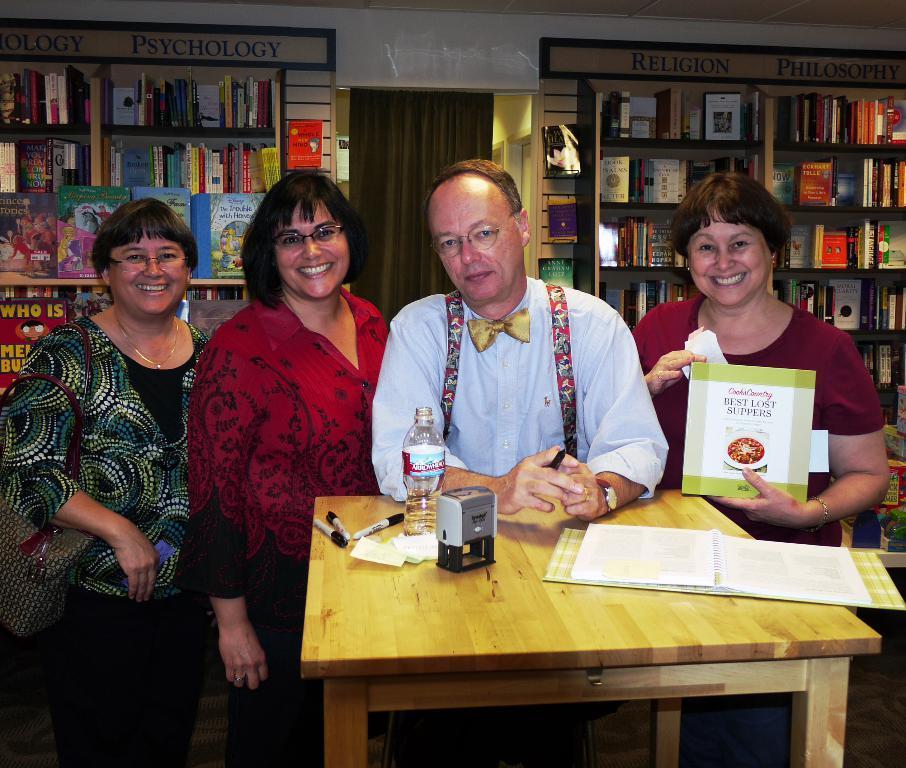In one or two sentences, can you explain what this image depicts? This persons are standing. In-front of this person's there is a table, on a table there is a book, stamp, bottle and markers. This woman is holding a bag. This woman is holding a card. In a race there are number of books. 